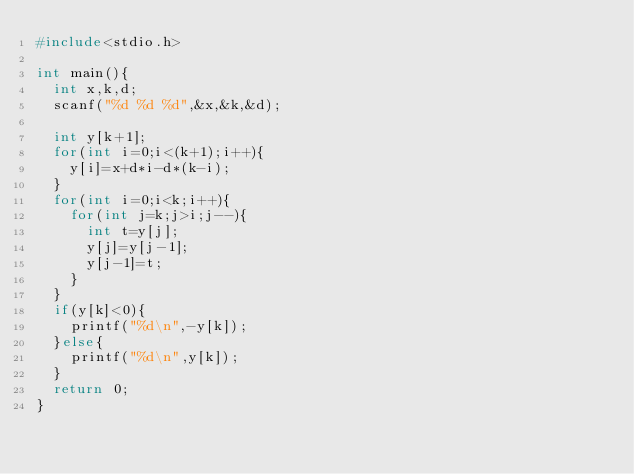Convert code to text. <code><loc_0><loc_0><loc_500><loc_500><_C_>#include<stdio.h>
 
int main(){
  int x,k,d;
  scanf("%d %d %d",&x,&k,&d);
  
  int y[k+1];
  for(int i=0;i<(k+1);i++){
    y[i]=x+d*i-d*(k-i);
  }
  for(int i=0;i<k;i++){
    for(int j=k;j>i;j--){
      int t=y[j];
      y[j]=y[j-1];
      y[j-1]=t;
    }
  }
  if(y[k]<0){
    printf("%d\n",-y[k]);
  }else{
    printf("%d\n",y[k]);
  }
  return 0;
}</code> 